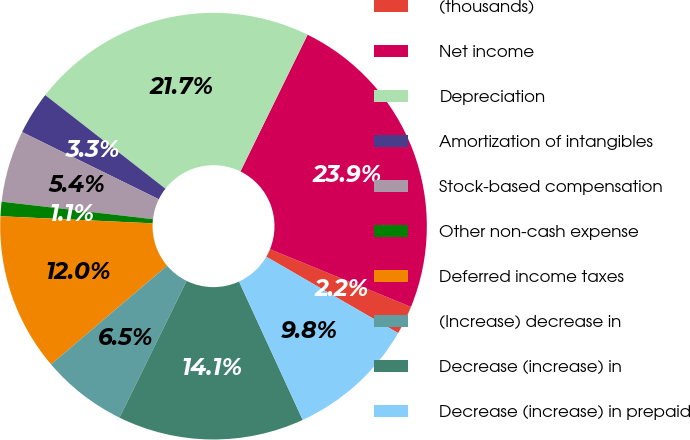Convert chart. <chart><loc_0><loc_0><loc_500><loc_500><pie_chart><fcel>(thousands)<fcel>Net income<fcel>Depreciation<fcel>Amortization of intangibles<fcel>Stock-based compensation<fcel>Other non-cash expense<fcel>Deferred income taxes<fcel>(Increase) decrease in<fcel>Decrease (increase) in<fcel>Decrease (increase) in prepaid<nl><fcel>2.18%<fcel>23.91%<fcel>21.74%<fcel>3.26%<fcel>5.44%<fcel>1.09%<fcel>11.96%<fcel>6.52%<fcel>14.13%<fcel>9.78%<nl></chart> 